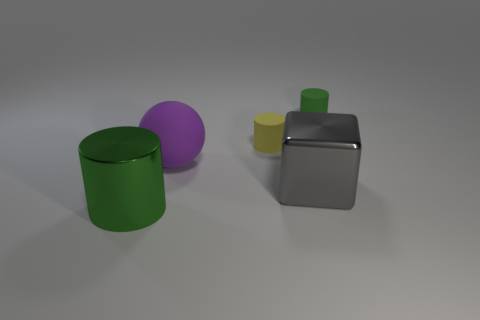Add 3 big things. How many objects exist? 8 Subtract all cylinders. How many objects are left? 2 Add 5 small yellow cylinders. How many small yellow cylinders are left? 6 Add 2 small rubber blocks. How many small rubber blocks exist? 2 Subtract 0 cyan balls. How many objects are left? 5 Subtract all matte objects. Subtract all small rubber spheres. How many objects are left? 2 